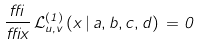<formula> <loc_0><loc_0><loc_500><loc_500>\frac { \delta } { \delta x } \, \mathcal { L } ^ { ( 1 ) } _ { u , v } \, ( x \, | \, a , b , c , d ) \, = 0</formula> 